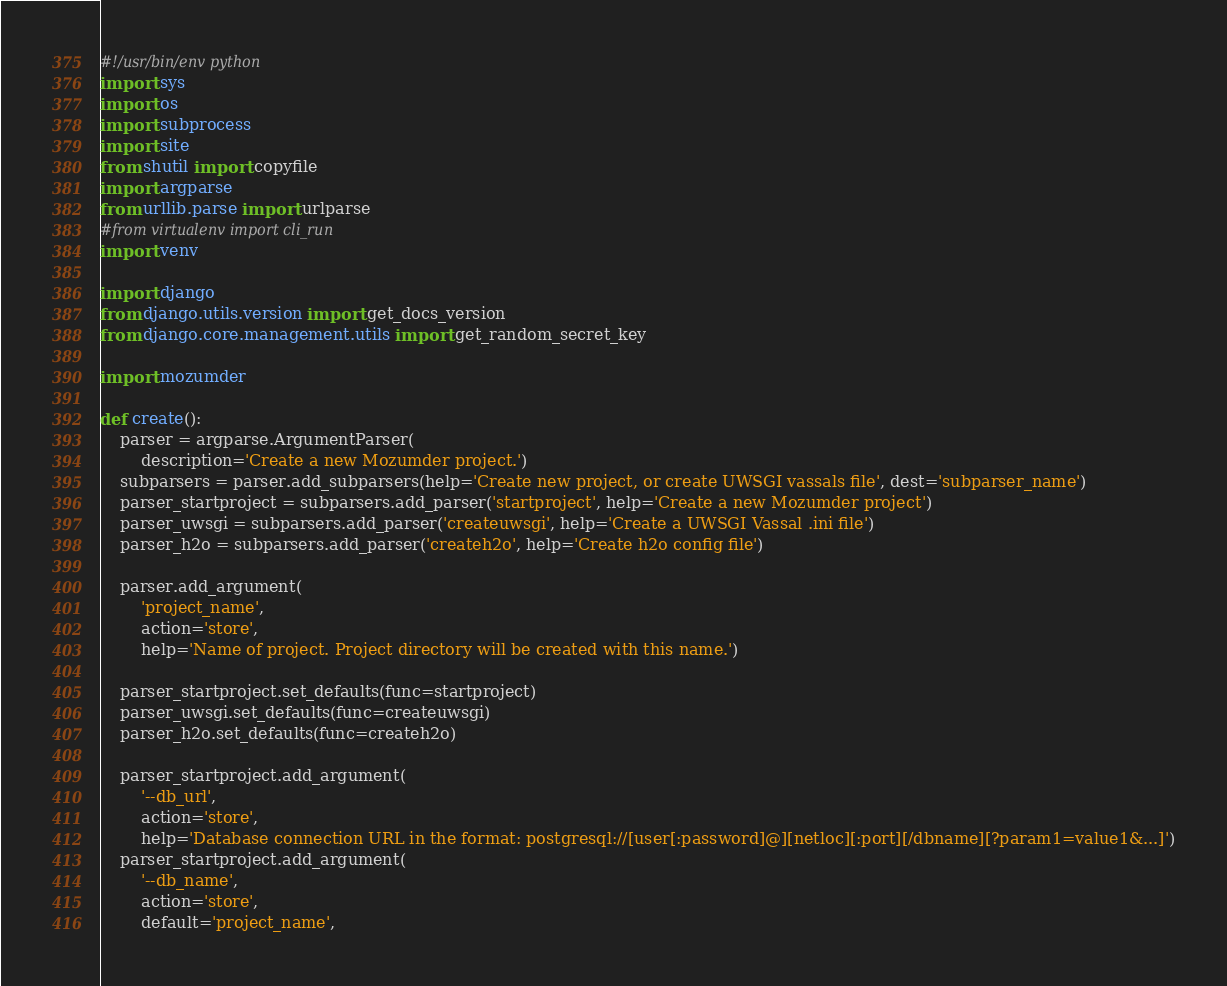Convert code to text. <code><loc_0><loc_0><loc_500><loc_500><_Python_>#!/usr/bin/env python
import sys
import os
import subprocess
import site
from shutil import copyfile
import argparse
from urllib.parse import urlparse
#from virtualenv import cli_run
import venv

import django
from django.utils.version import get_docs_version
from django.core.management.utils import get_random_secret_key

import mozumder

def create():
    parser = argparse.ArgumentParser(
        description='Create a new Mozumder project.')
    subparsers = parser.add_subparsers(help='Create new project, or create UWSGI vassals file', dest='subparser_name')
    parser_startproject = subparsers.add_parser('startproject', help='Create a new Mozumder project')
    parser_uwsgi = subparsers.add_parser('createuwsgi', help='Create a UWSGI Vassal .ini file')
    parser_h2o = subparsers.add_parser('createh2o', help='Create h2o config file')

    parser.add_argument(
        'project_name',
        action='store',
        help='Name of project. Project directory will be created with this name.')

    parser_startproject.set_defaults(func=startproject)
    parser_uwsgi.set_defaults(func=createuwsgi)
    parser_h2o.set_defaults(func=createh2o)

    parser_startproject.add_argument(
        '--db_url',
        action='store',
        help='Database connection URL in the format: postgresql://[user[:password]@][netloc][:port][/dbname][?param1=value1&...]')
    parser_startproject.add_argument(
        '--db_name',
        action='store',
        default='project_name',</code> 